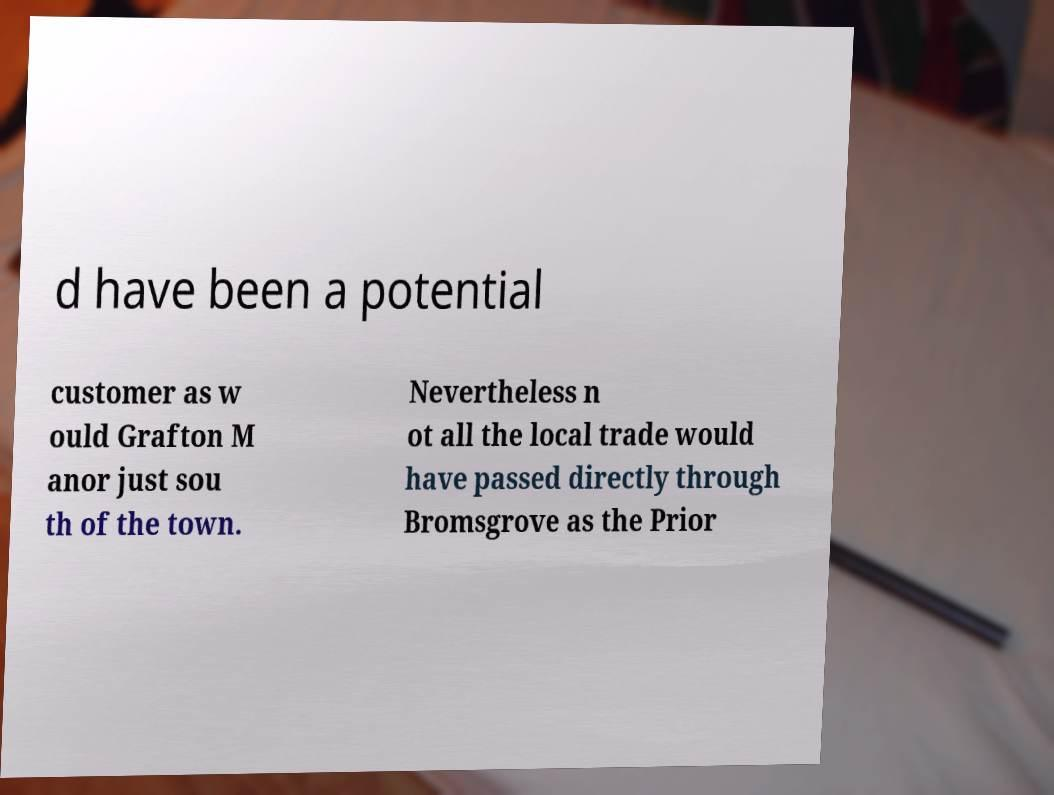Could you extract and type out the text from this image? d have been a potential customer as w ould Grafton M anor just sou th of the town. Nevertheless n ot all the local trade would have passed directly through Bromsgrove as the Prior 